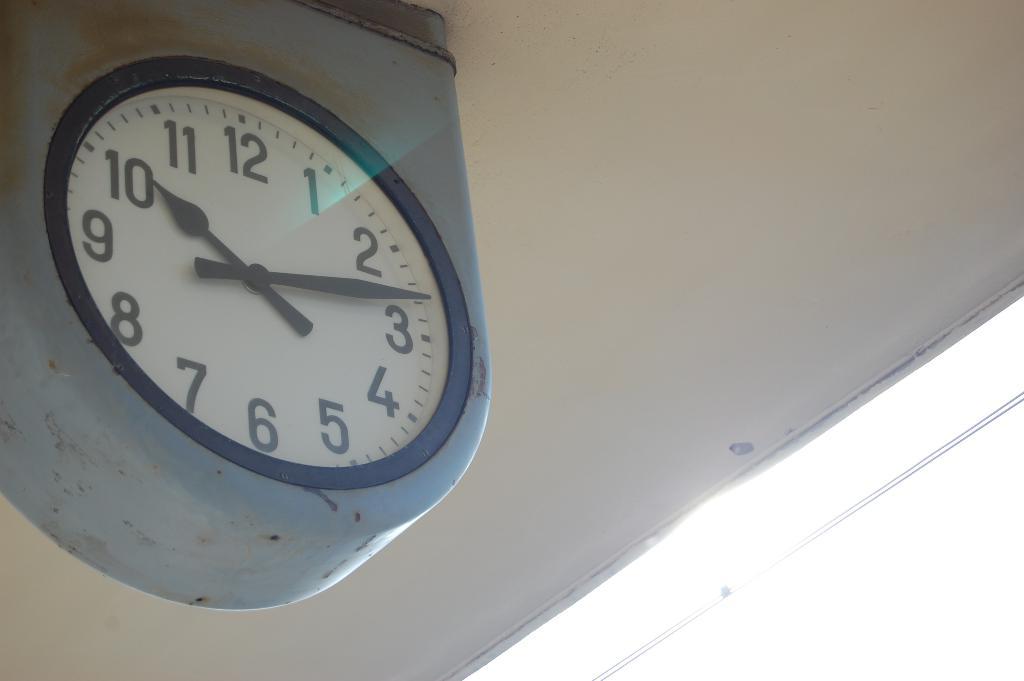What time does the clock say?
Offer a very short reply. 10:13. 